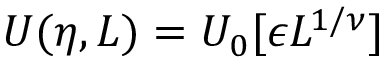<formula> <loc_0><loc_0><loc_500><loc_500>U ( \eta , L ) = U _ { 0 } [ \epsilon L ^ { 1 / \nu } ]</formula> 